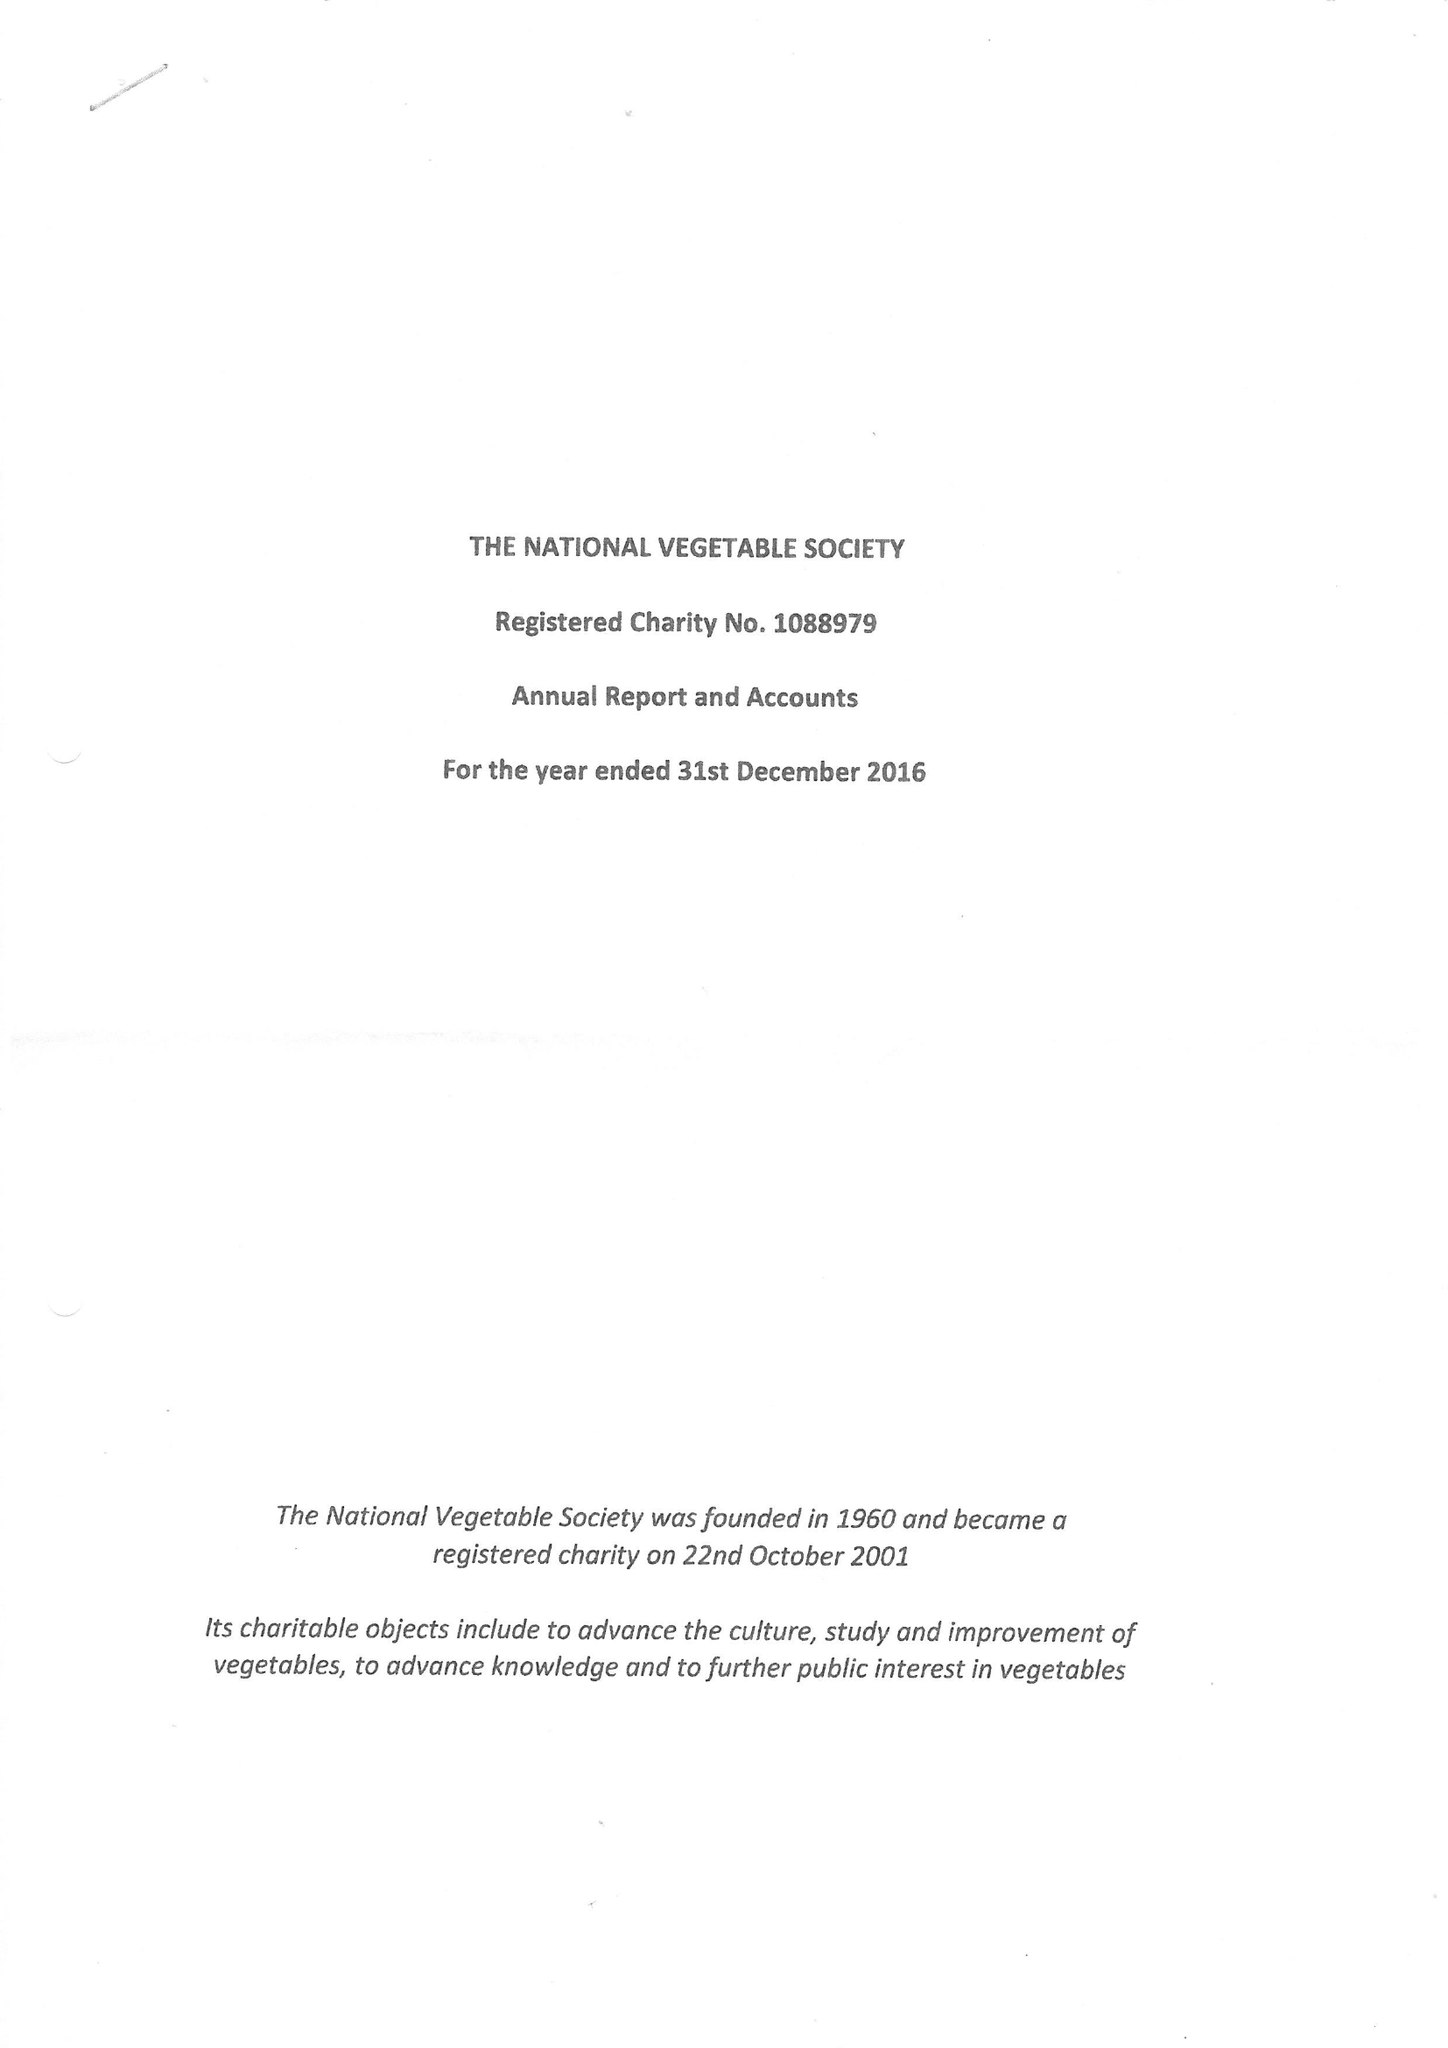What is the value for the charity_number?
Answer the question using a single word or phrase. 1088979 